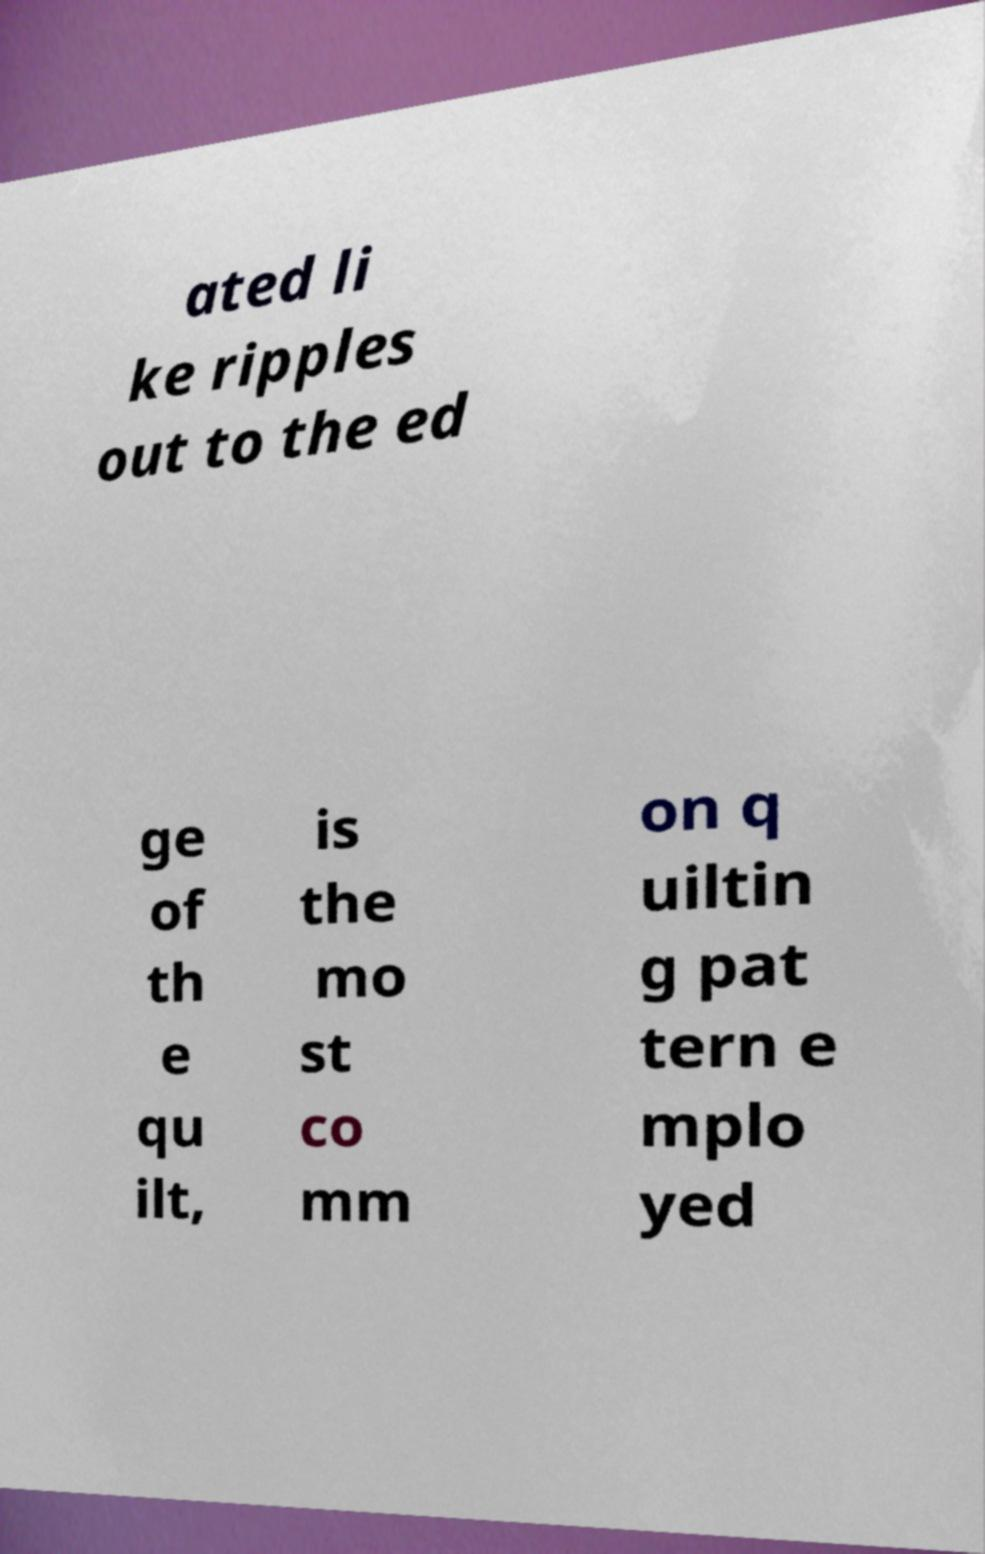There's text embedded in this image that I need extracted. Can you transcribe it verbatim? ated li ke ripples out to the ed ge of th e qu ilt, is the mo st co mm on q uiltin g pat tern e mplo yed 